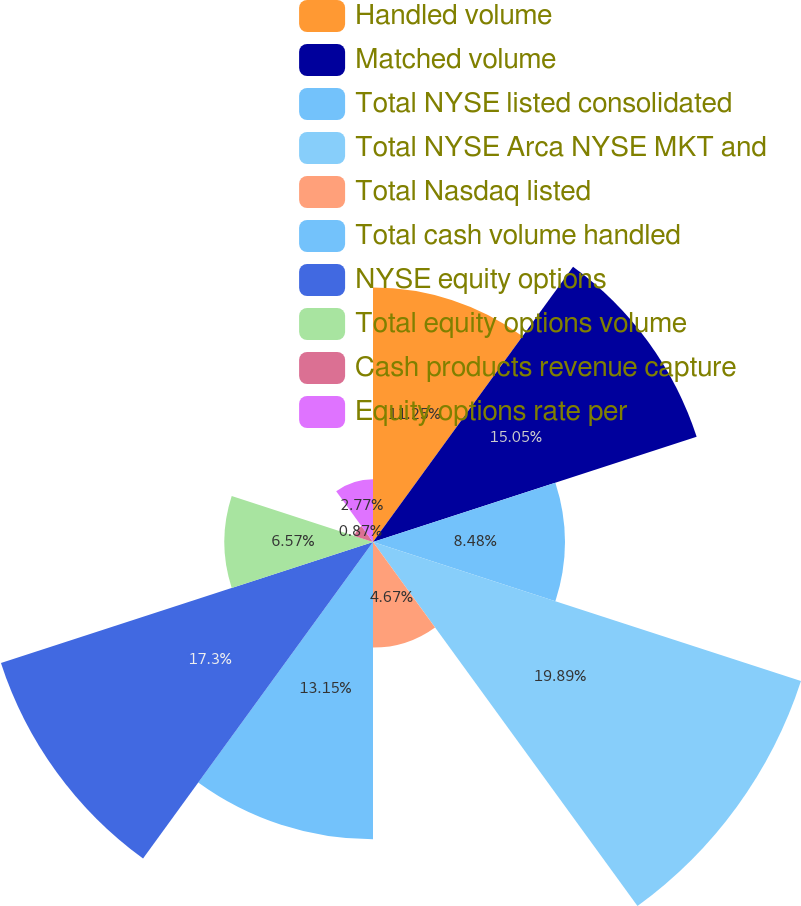<chart> <loc_0><loc_0><loc_500><loc_500><pie_chart><fcel>Handled volume<fcel>Matched volume<fcel>Total NYSE listed consolidated<fcel>Total NYSE Arca NYSE MKT and<fcel>Total Nasdaq listed<fcel>Total cash volume handled<fcel>NYSE equity options<fcel>Total equity options volume<fcel>Cash products revenue capture<fcel>Equity options rate per<nl><fcel>11.25%<fcel>15.05%<fcel>8.48%<fcel>19.9%<fcel>4.67%<fcel>13.15%<fcel>17.3%<fcel>6.57%<fcel>0.87%<fcel>2.77%<nl></chart> 